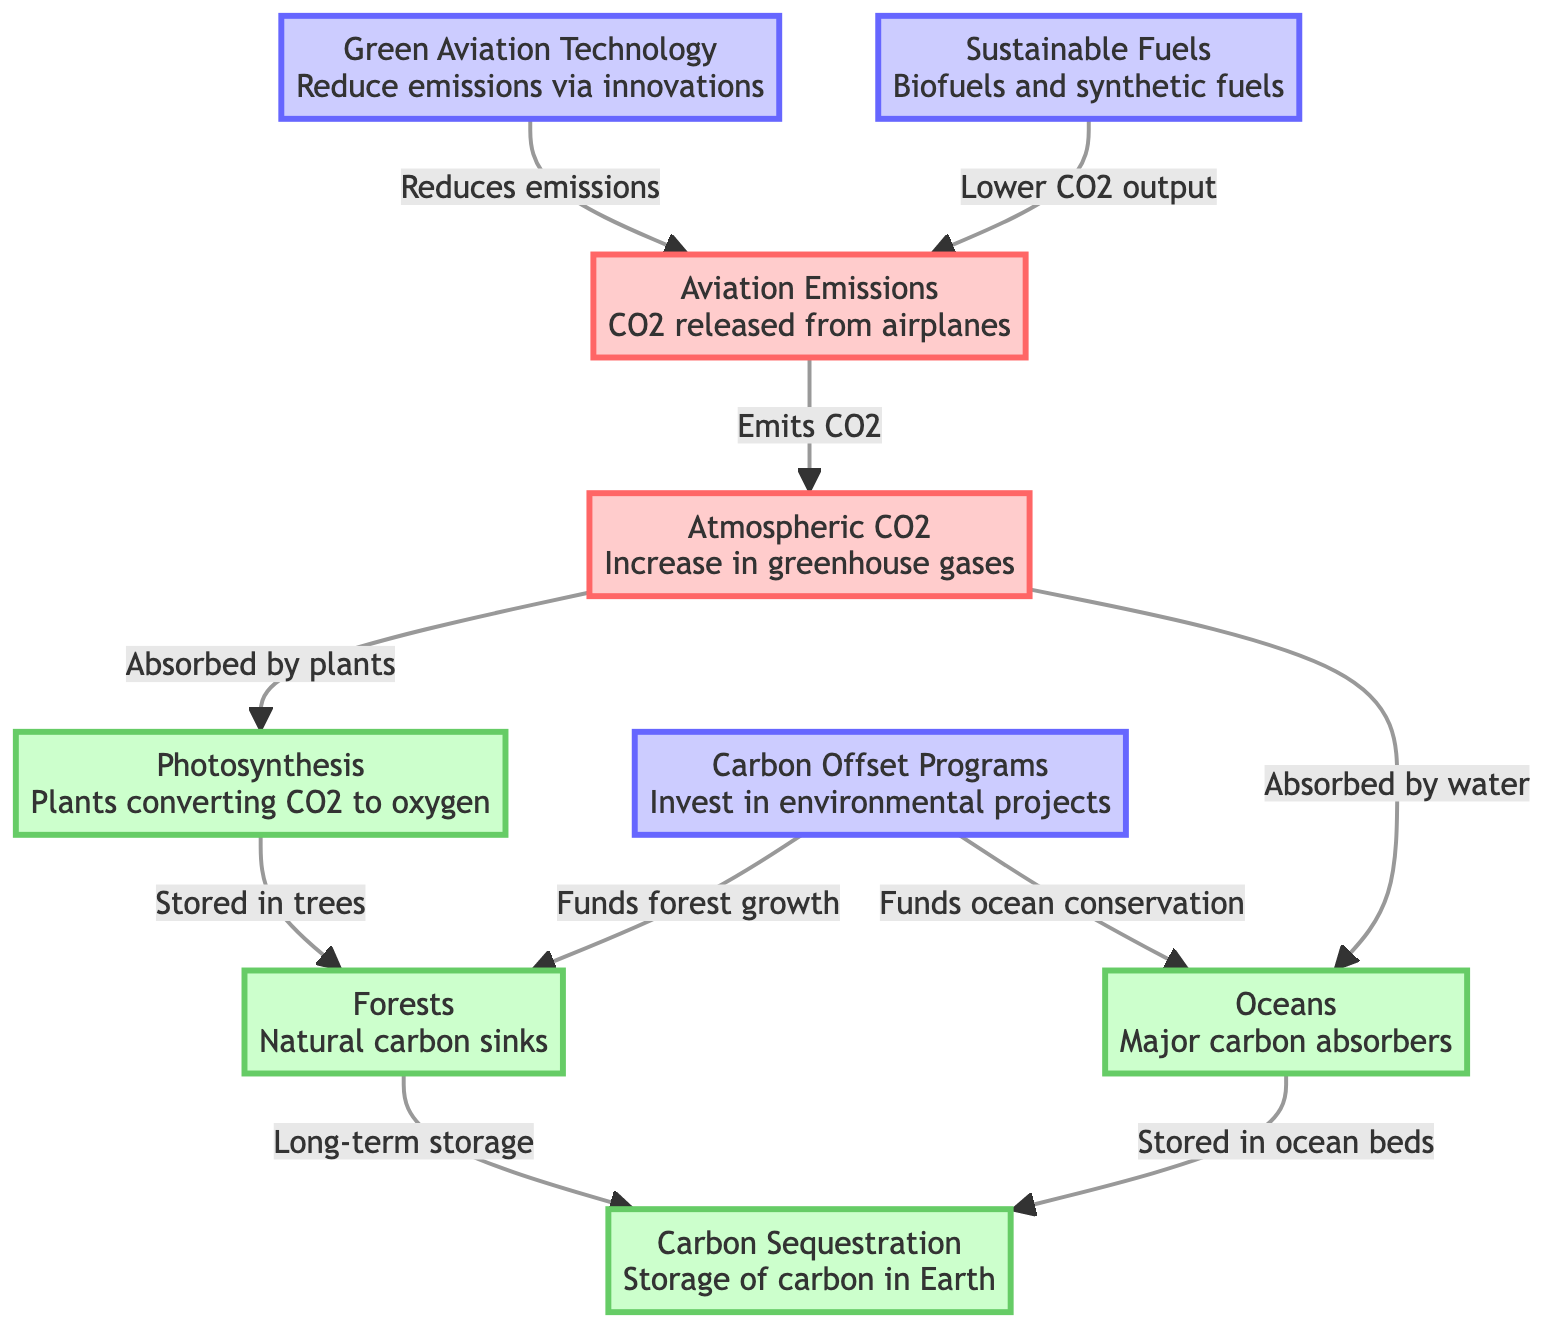What are the two main sources of carbon emissions from aviation? The diagram identifies "Aviation Emissions" and the lack of "Green Aviation Technology" as sources of carbon emissions from aviation, indicating the first leads to atmospheric CO2.
Answer: Aviation Emissions, Green Aviation Technology Which natural process absorbs atmospheric CO2? The diagram shows that "Photosynthesis" is the process that absorbs atmospheric CO2; it connects directly to "Atmospheric CO2" in the flow.
Answer: Photosynthesis How are forests related to carbon sequestration? The flow indicates that trees store carbon absorbed from photosynthesis, which is then transferred to "Carbon Sequestration," illustrating the role of forests.
Answer: Long-term storage How many nodes are present in the diagram? By counting each unique concept in the flowchart, there are a total of eight nodes represented in the diagram.
Answer: 8 What role do carbon offset programs play in forests and oceans? The diagram illustrates that "Carbon Offset Programs" fund both the growth of forests and the conservation of oceans, showing their supportive roles in carbon management.
Answer: Funds forest growth, Funds ocean conservation Which technology helps to reduce aviation emissions? The diagram lists "Green Aviation Technology" as a direct technology intended to reduce aviation emissions, indicating its role in the process.
Answer: Green Aviation Technology What is a major carbon absorber in the carbon cycle? The diagram specifically identifies "Oceans" as a major sink for CO2 absorption, reflecting their significance in the carbon cycle.
Answer: Oceans What is the relationship between atmospheric CO2 and sustainable fuels? The diagram indicates that while atmospheric CO2 is present, "Sustainable Fuels" help lower CO2 output from aviation, showcasing their mitigating effect.
Answer: Lower CO2 output How is carbon stored in ocean beds according to the diagram? The diagram shows the pathway from "Atmospheric CO2" absorbed by "Oceans," which retains carbon in "Carbon Sequestration," specifically in ocean beds.
Answer: Stored in ocean beds 